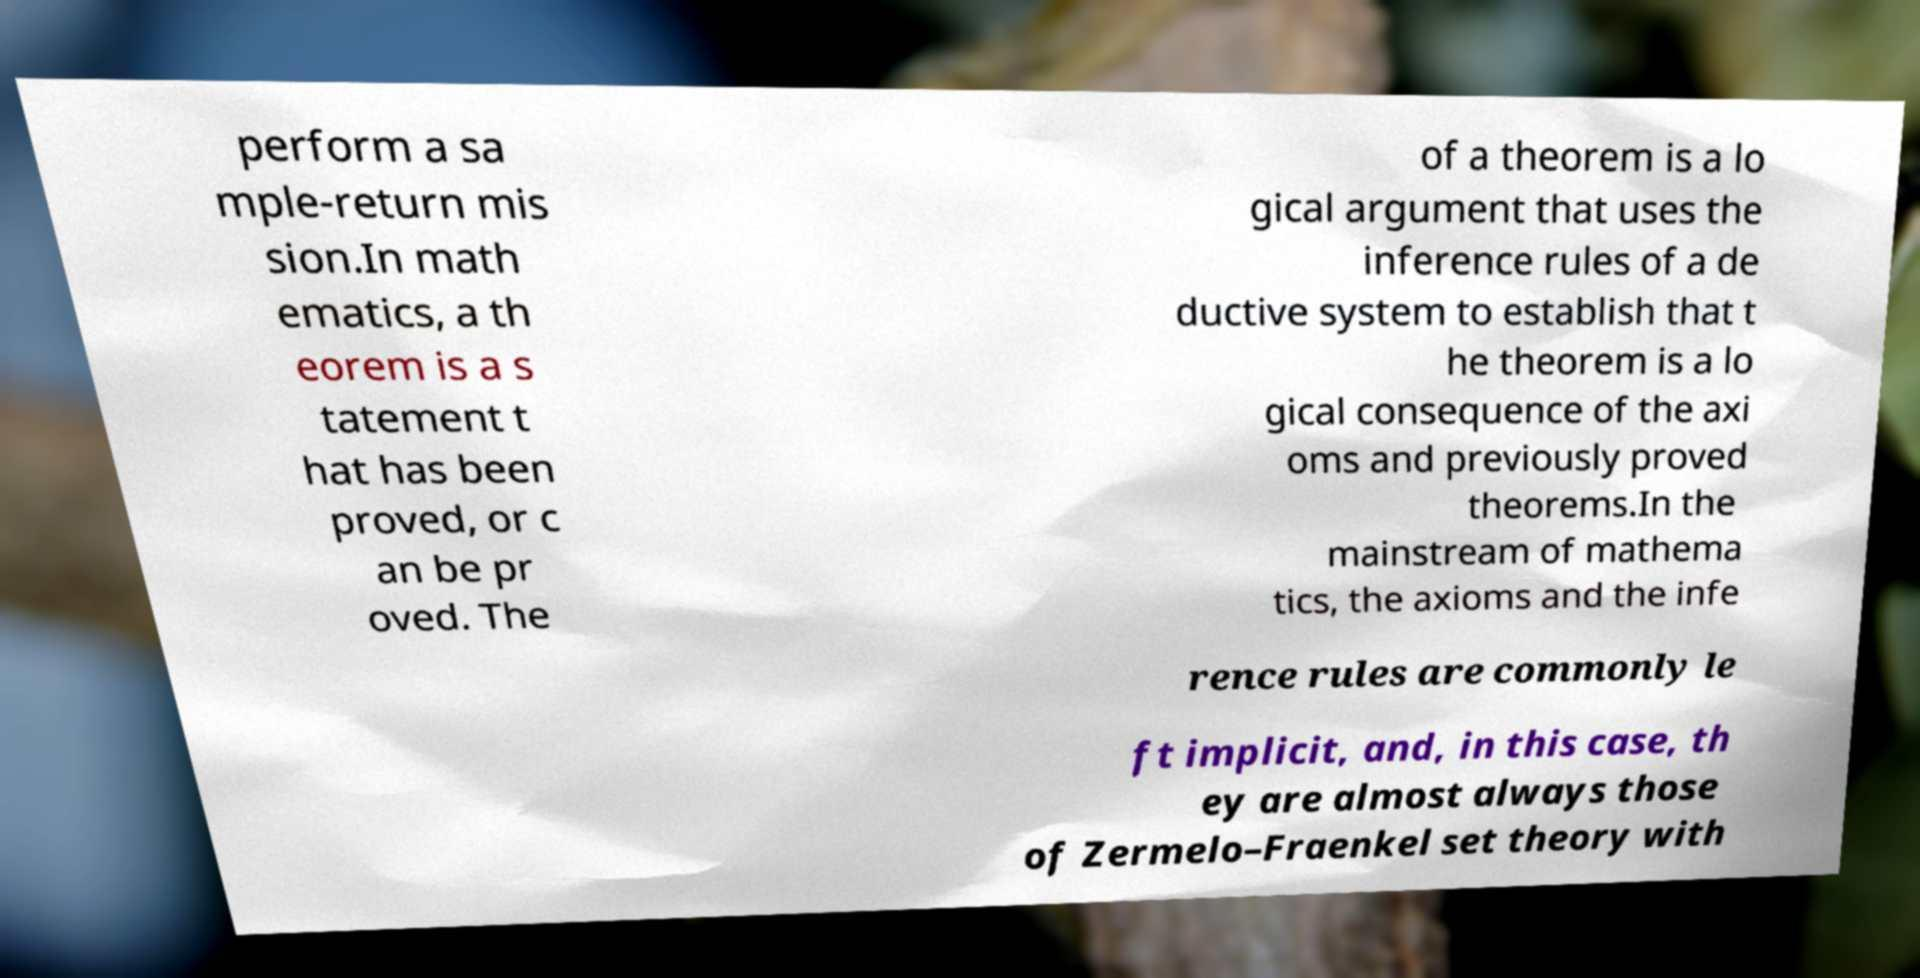Can you read and provide the text displayed in the image?This photo seems to have some interesting text. Can you extract and type it out for me? perform a sa mple-return mis sion.In math ematics, a th eorem is a s tatement t hat has been proved, or c an be pr oved. The of a theorem is a lo gical argument that uses the inference rules of a de ductive system to establish that t he theorem is a lo gical consequence of the axi oms and previously proved theorems.In the mainstream of mathema tics, the axioms and the infe rence rules are commonly le ft implicit, and, in this case, th ey are almost always those of Zermelo–Fraenkel set theory with 